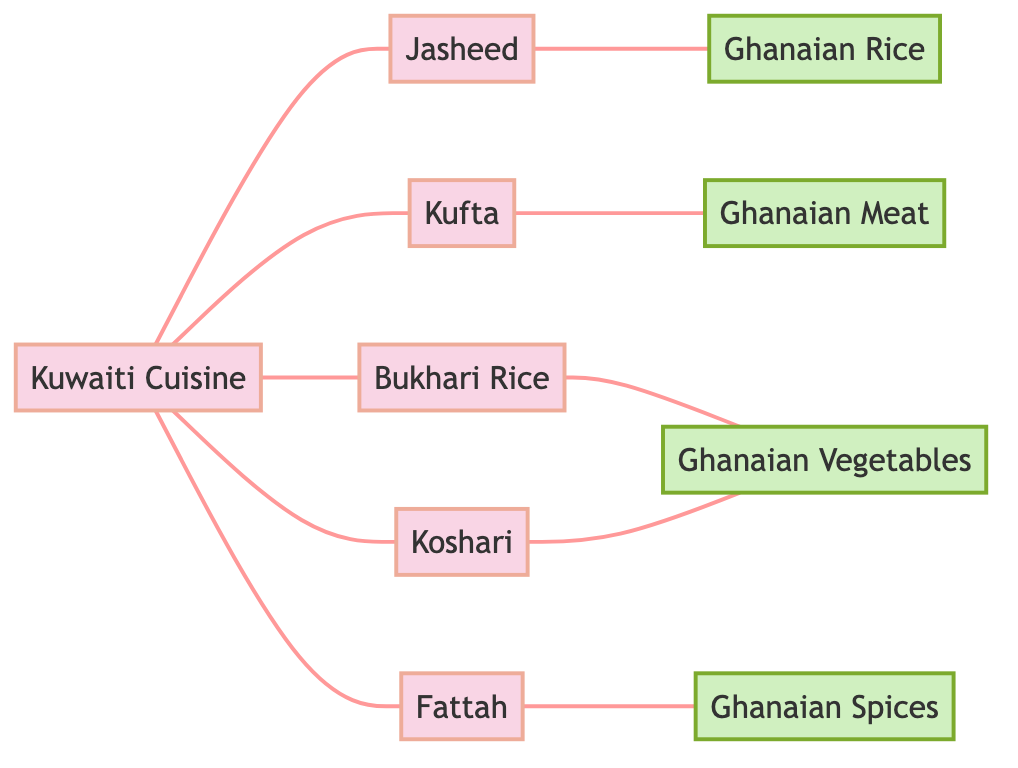What is the total number of nodes in the diagram? By counting the nodes listed in the data, we identify 10 distinct nodes, which include both Kuwaiti dishes and Ghanaian ingredients.
Answer: 10 Which Kuwaiti dish is connected to Ghanaian Rice? The diagram shows that Jasheed is directly connected to Ghanaian Rice, indicating a relationship between the two.
Answer: Jasheed How many edges connect Kuwaiti Cuisine to other dishes? Kuwaiti Cuisine has edges connecting it to five different dishes, which are Jasheed, Kufta, Bukhari Rice, Fattah, and Koshari.
Answer: 5 Which Ghanaian ingredient is associated with the dish Kufta? According to the connections in the diagram, Ghanaian Meat is the ingredient linked to the dish Kufta.
Answer: Ghanaian Meat What are the Ghanaian ingredients linked to Bukhari Rice? In the diagram, the only Ghanaian ingredient connected to Bukhari Rice is Ghanaian Vegetables.
Answer: Ghanaian Vegetables Which Kuwaiti dish has connections to both Ghanaian Vegetables and Ghanaian Spices? Fattah is the Kuwaiti dish that is linked to Ghanaian Spices, while Koshari connects to Ghanaian Vegetables according to the diagram.
Answer: Fattah and Koshari How many connections does Ghanaian Spices have in the graph? Ghanaian Spices has only one connection in the diagram, which links it to the dish Fattah.
Answer: 1 Are there any Ghanaian ingredients not directly linked to any Kuwaiti dishes? Upon reviewing the diagram, each Ghanaian ingredient is linked to a Kuwaiti dish, so no ingredient stands alone.
Answer: No Which two nodes share a direct connection with both Ghanaian Vegetables and Ghanaian Rice? Analyzing the graph, we see that Bukhari Rice connects to Ghanaian Vegetables and Jasheed connects to Ghanaian Rice, making these two nodes share indirect connections through different Ghanaian ingredients.
Answer: Bukhari Rice and Jasheed 